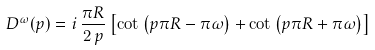Convert formula to latex. <formula><loc_0><loc_0><loc_500><loc_500>D ^ { \omega } ( p ) = i \, \frac { \pi R } { 2 \, p } \left [ \cot \left ( p \pi R - \pi \omega \right ) + \cot \left ( p \pi R + \pi \omega \right ) \right ]</formula> 